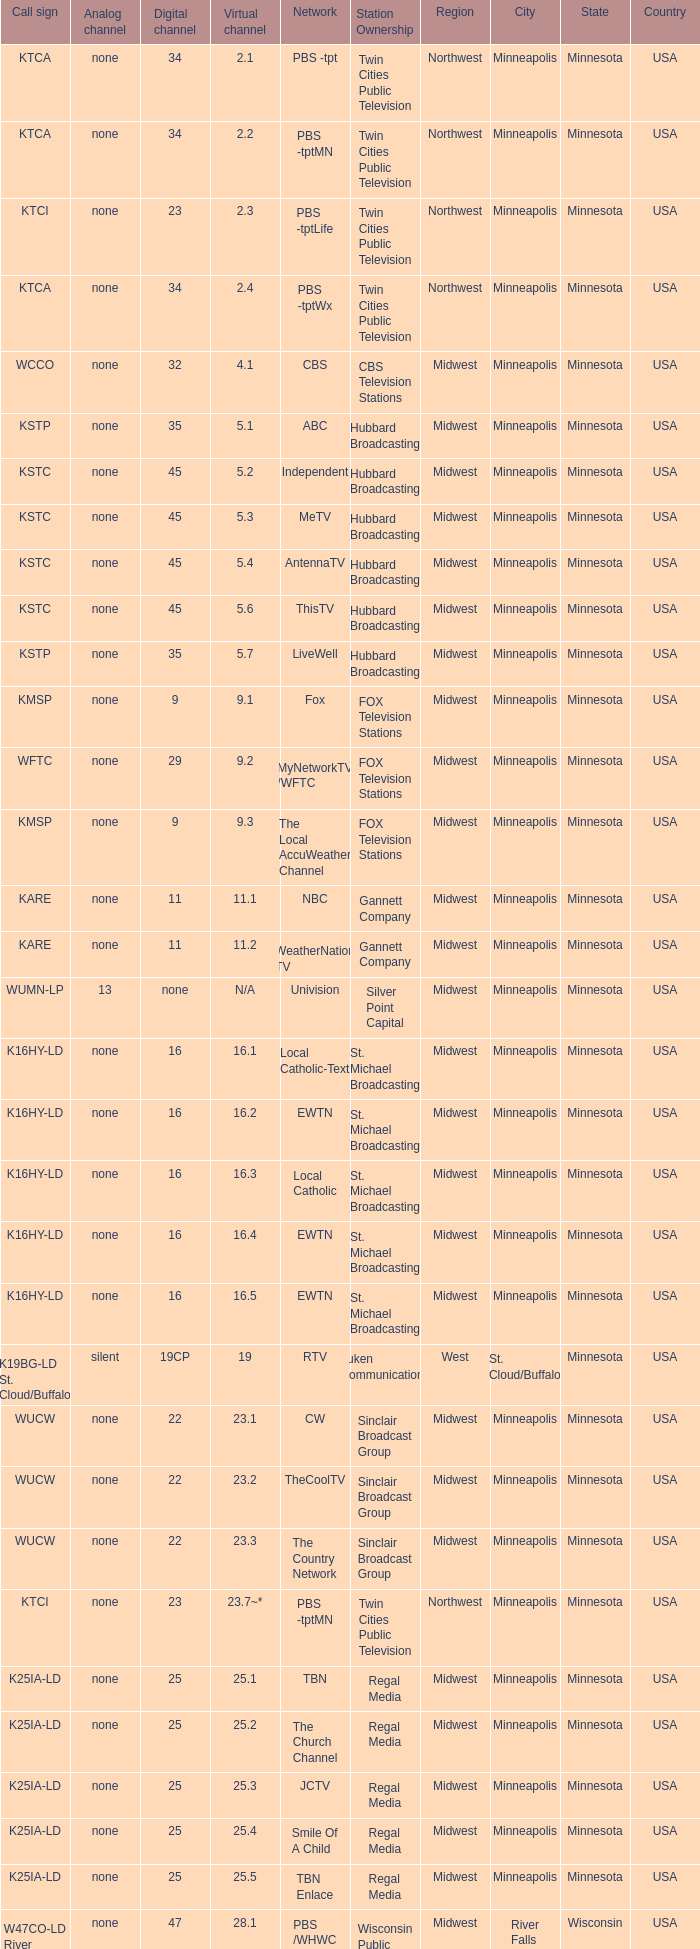Call sign of k33ln-ld, and a Virtual channel of 33.5 is what network? 3ABN Radio-Audio. 